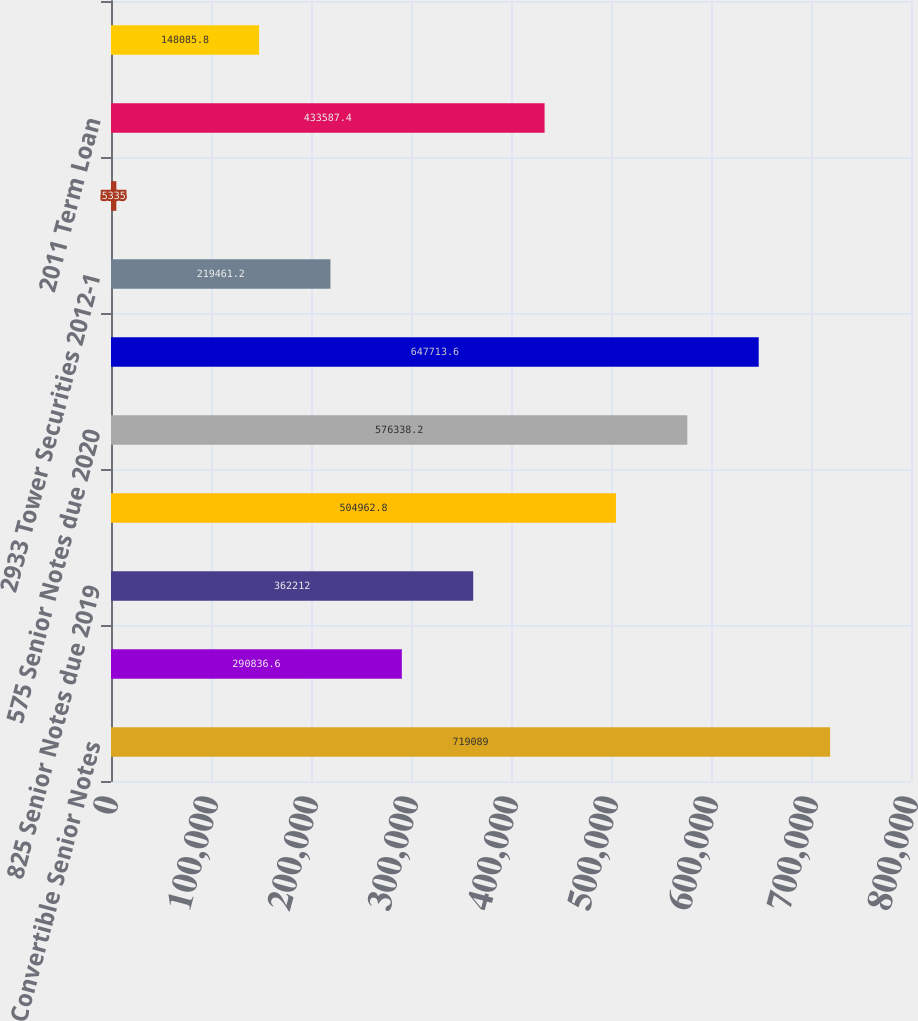Convert chart. <chart><loc_0><loc_0><loc_500><loc_500><bar_chart><fcel>1875 Convertible Senior Notes<fcel>40 Convertible Senior Notes<fcel>825 Senior Notes due 2019<fcel>5625 Senior Notes due 2019<fcel>575 Senior Notes due 2020<fcel>4254 and 5101 Tower Securities<fcel>2933 Tower Securities 2012-1<fcel>Revolving Credit Facility<fcel>2011 Term Loan<fcel>2012-1 Term Loan<nl><fcel>719089<fcel>290837<fcel>362212<fcel>504963<fcel>576338<fcel>647714<fcel>219461<fcel>5335<fcel>433587<fcel>148086<nl></chart> 